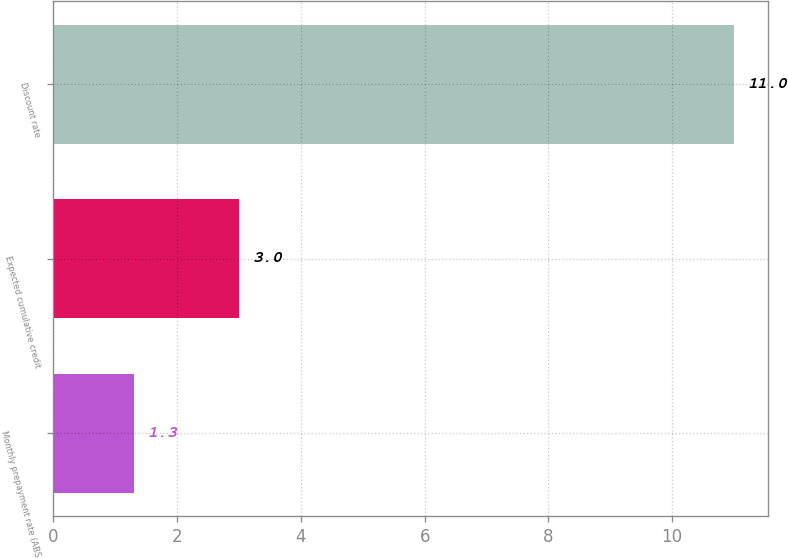<chart> <loc_0><loc_0><loc_500><loc_500><bar_chart><fcel>Monthly prepayment rate (ABS<fcel>Expected cumulative credit<fcel>Discount rate<nl><fcel>1.3<fcel>3<fcel>11<nl></chart> 